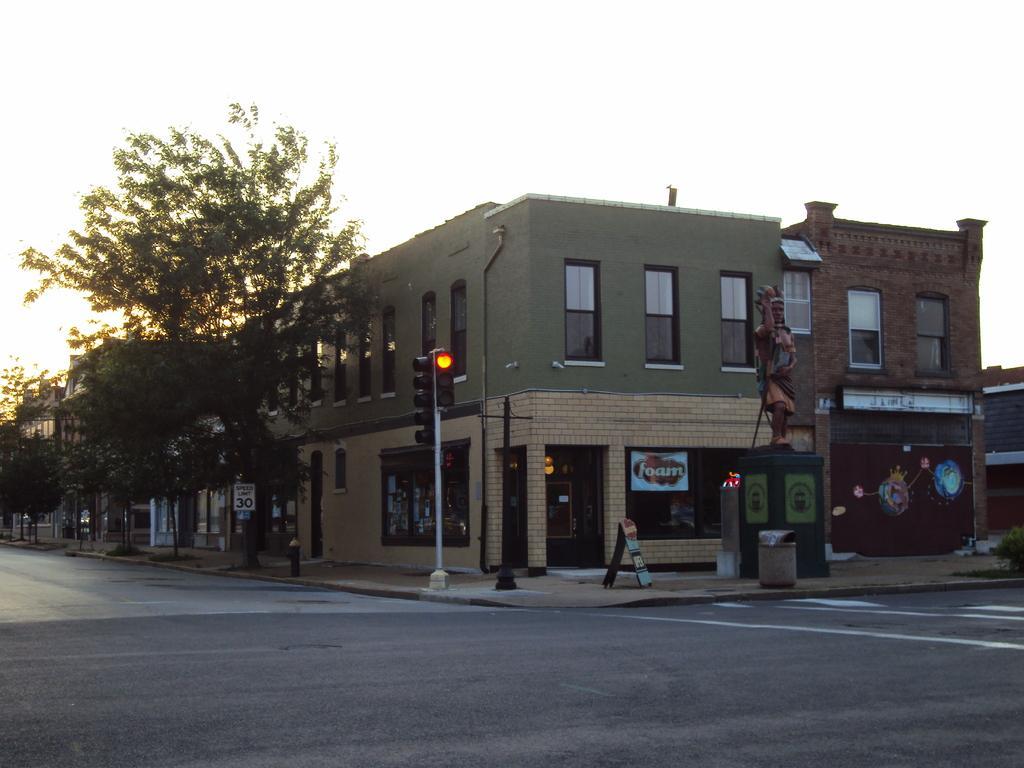Please provide a concise description of this image. In the background of the image there is a building. There is a street light. There are trees. At the bottom of the image there is road. 